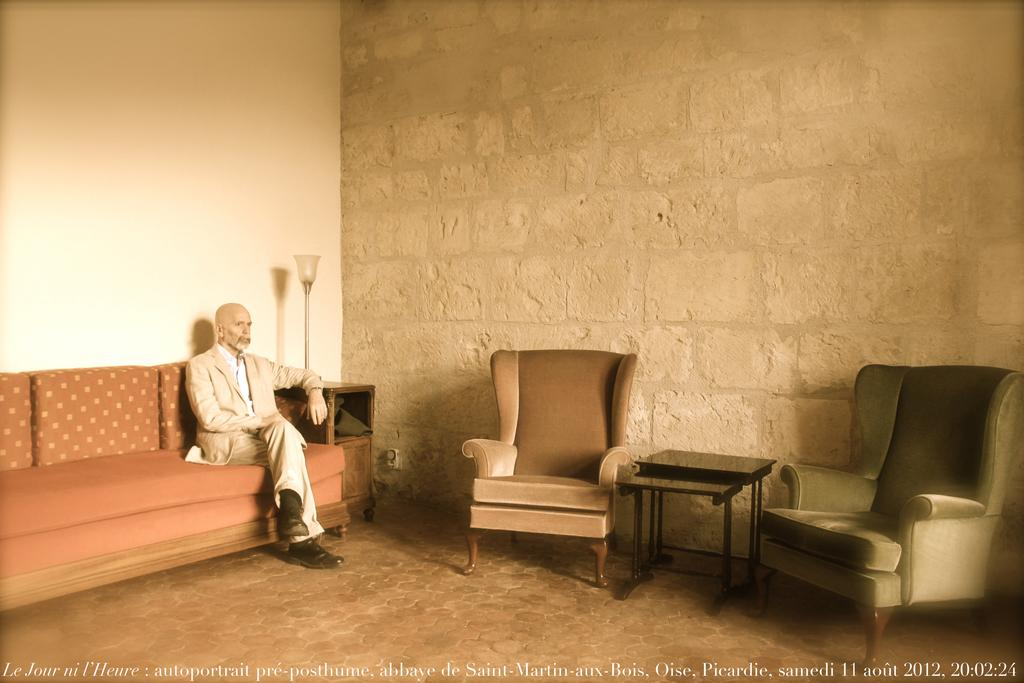Who is present in the image? There is a man in the image. What is the man doing in the image? The man is sitting on a sofa. Are there any other seating options visible in the image? Yes, there are chairs in the image. How many girls are sitting at the lunchroom table in the image? There are no girls or lunchroom table present in the image. What type of straw is being used to stir the man's drink in the image? There is no drink or straw present in the image. 